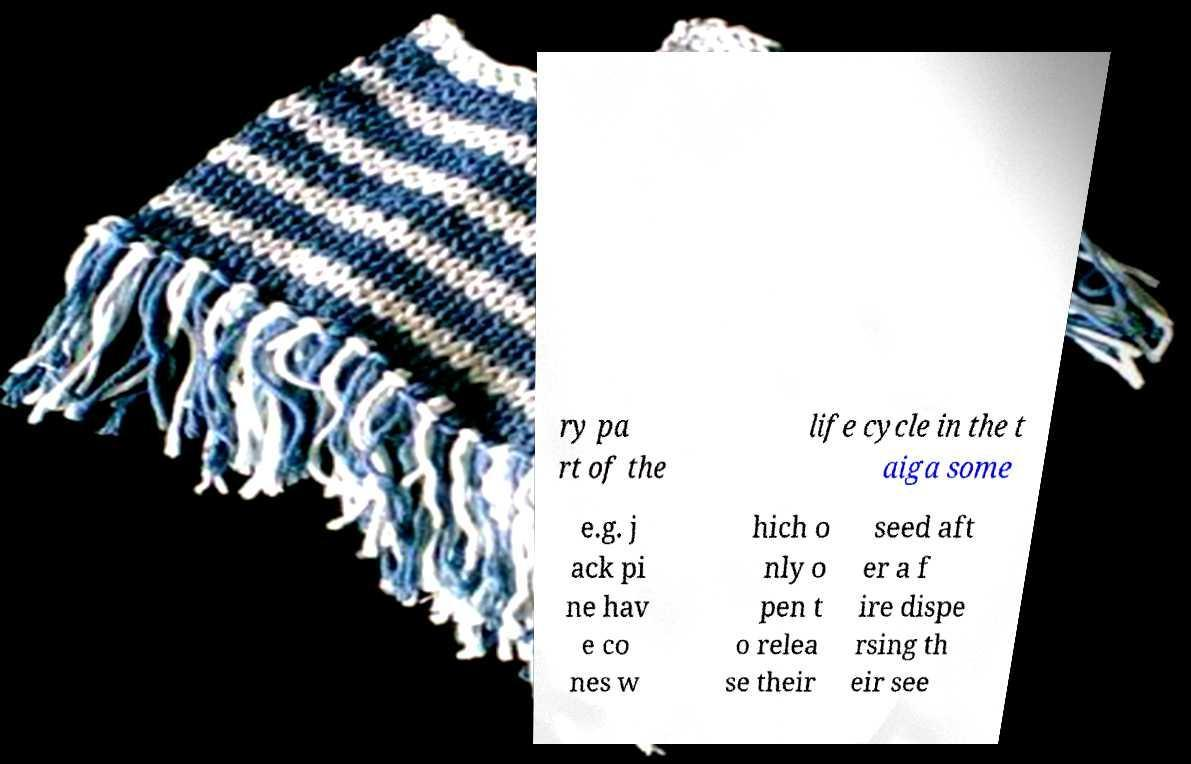There's text embedded in this image that I need extracted. Can you transcribe it verbatim? ry pa rt of the life cycle in the t aiga some e.g. j ack pi ne hav e co nes w hich o nly o pen t o relea se their seed aft er a f ire dispe rsing th eir see 